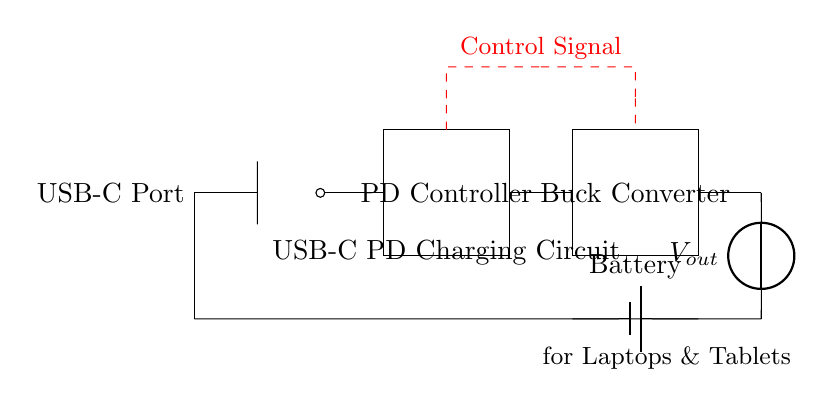What is the component responsible for voltage regulation? The Buck Converter in the circuit is responsible for stepping down the voltage to the required output level. It converts a higher input voltage to a lower output voltage as needed by the connected device.
Answer: Buck Converter What is the output voltage represented as? The output voltage is denoted by the symbol "V out" in the circuit. It indicates the voltage level provided to the load for charging the device.
Answer: V out How many main components are in this circuit? There are four main components: USB-C Port, Power Delivery Controller, Buck Converter, and Battery. Each component plays a specific role in the charging circuit for laptops and tablets.
Answer: Four What is the direction of current flow in this circuit? The current flows from the USB-C Port through the Power Delivery Controller and Buck Converter to the Battery, ultimately outputting to the connected device. The diagram shows the path clearly with the connections between the components.
Answer: Forward What does the dashed red line represent? The dashed red line represents the control signal that manages the operation of the Power Delivery Controller and Buck Converter. It indicates communication between these components to ensure proper power delivery.
Answer: Control Signal Which component is the source of power in this circuit? The Battery is the source of power in this charging circuit. It stores energy and provides it to the device once properly charged through the converters and controllers.
Answer: Battery 